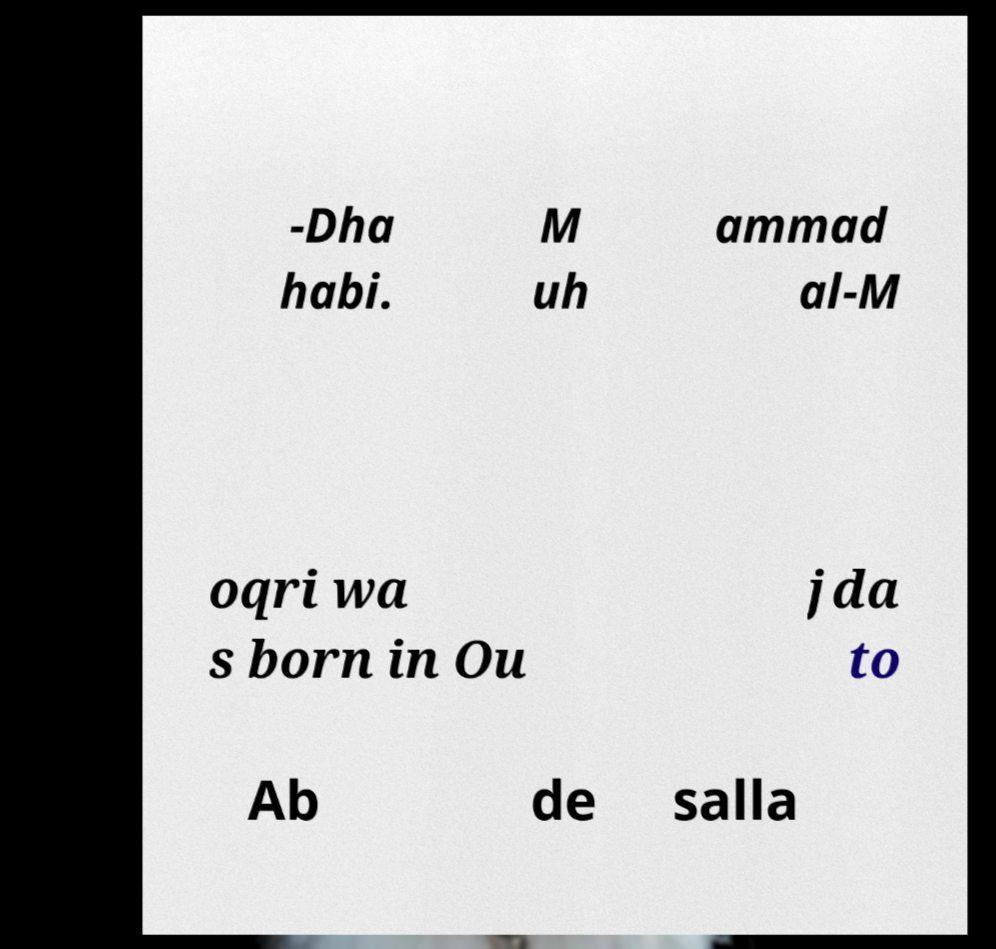Please identify and transcribe the text found in this image. -Dha habi. M uh ammad al-M oqri wa s born in Ou jda to Ab de salla 